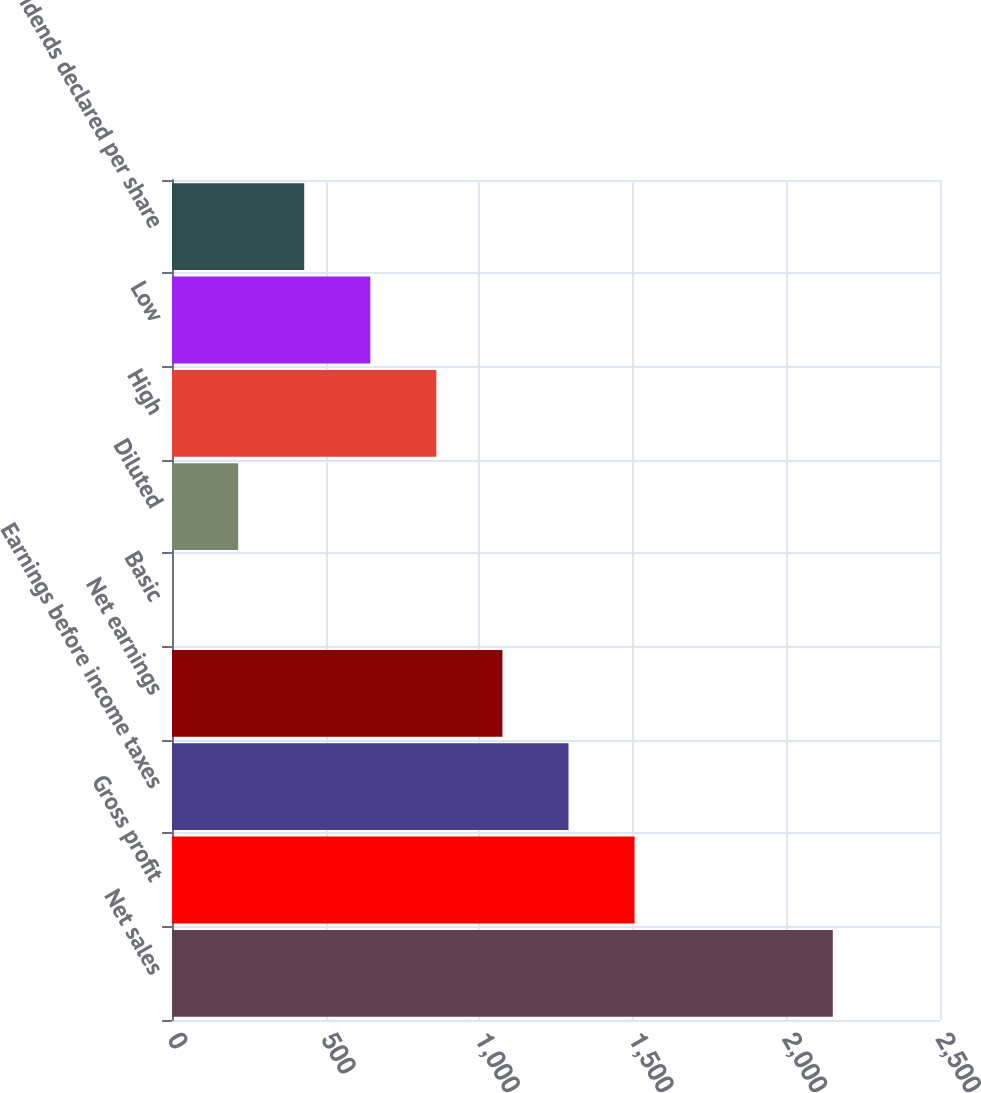<chart> <loc_0><loc_0><loc_500><loc_500><bar_chart><fcel>Net sales<fcel>Gross profit<fcel>Earnings before income taxes<fcel>Net earnings<fcel>Basic<fcel>Diluted<fcel>High<fcel>Low<fcel>Dividends declared per share<nl><fcel>2151<fcel>1505.76<fcel>1290.69<fcel>1075.62<fcel>0.27<fcel>215.34<fcel>860.55<fcel>645.48<fcel>430.41<nl></chart> 